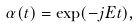<formula> <loc_0><loc_0><loc_500><loc_500>\alpha ( t ) = \exp ( - j E t ) ,</formula> 